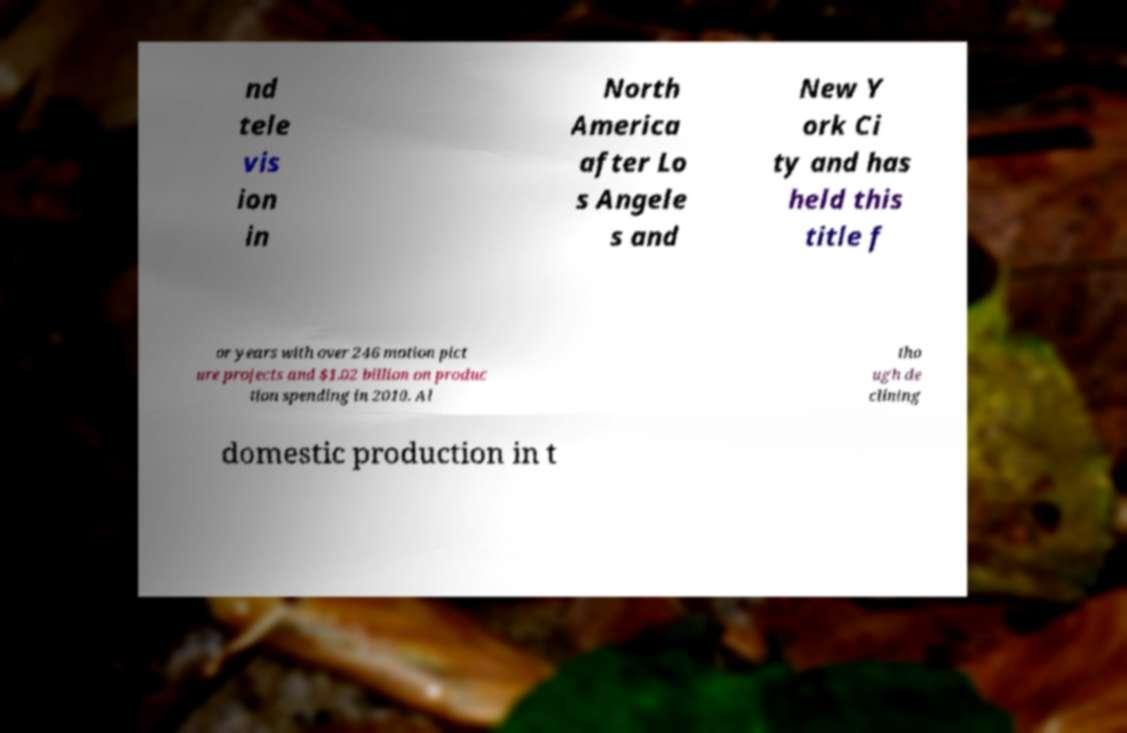Can you read and provide the text displayed in the image?This photo seems to have some interesting text. Can you extract and type it out for me? nd tele vis ion in North America after Lo s Angele s and New Y ork Ci ty and has held this title f or years with over 246 motion pict ure projects and $1.02 billion on produc tion spending in 2010. Al tho ugh de clining domestic production in t 